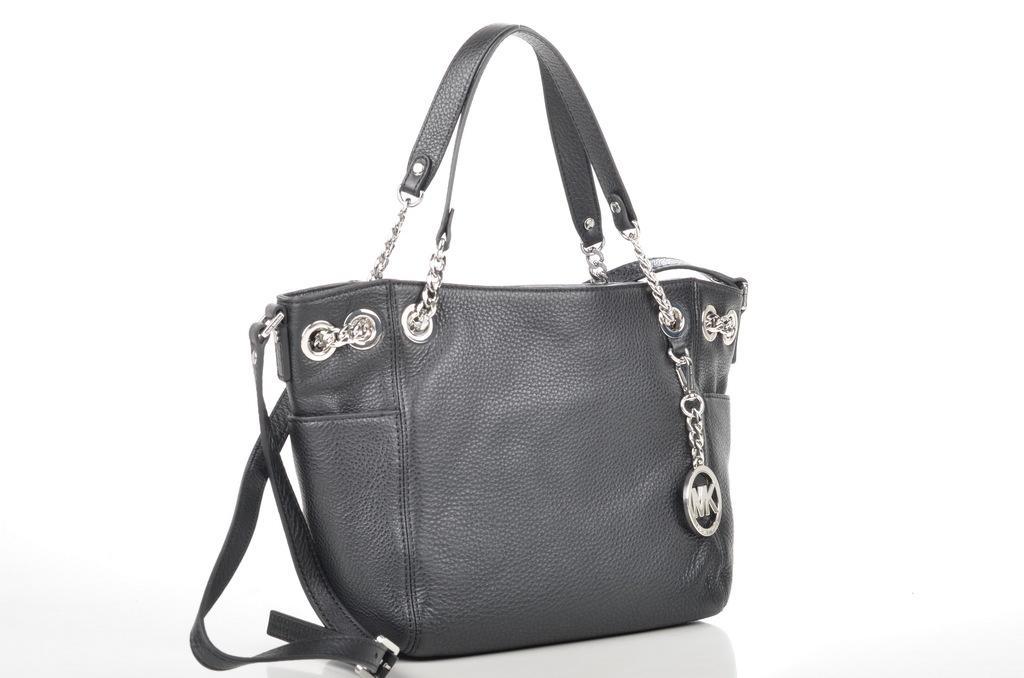In one or two sentences, can you explain what this image depicts? In the image there is a bag which is in black color. 